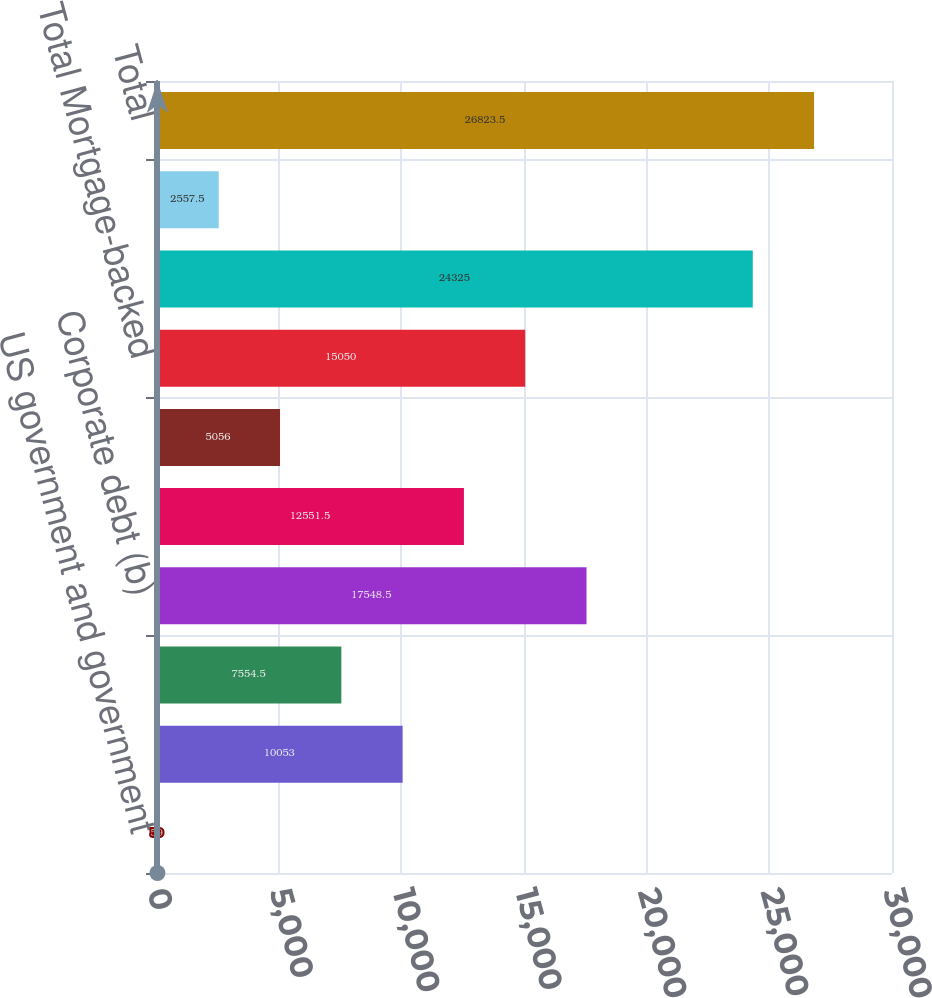Convert chart. <chart><loc_0><loc_0><loc_500><loc_500><bar_chart><fcel>US government and government<fcel>Obligations of states<fcel>Non-US governments<fcel>Corporate debt (b)<fcel>CMBS<fcel>CDO/ABS<fcel>Total Mortgage-backed<fcel>Totalbonds<fcel>Equity securities<fcel>Total<nl><fcel>59<fcel>10053<fcel>7554.5<fcel>17548.5<fcel>12551.5<fcel>5056<fcel>15050<fcel>24325<fcel>2557.5<fcel>26823.5<nl></chart> 